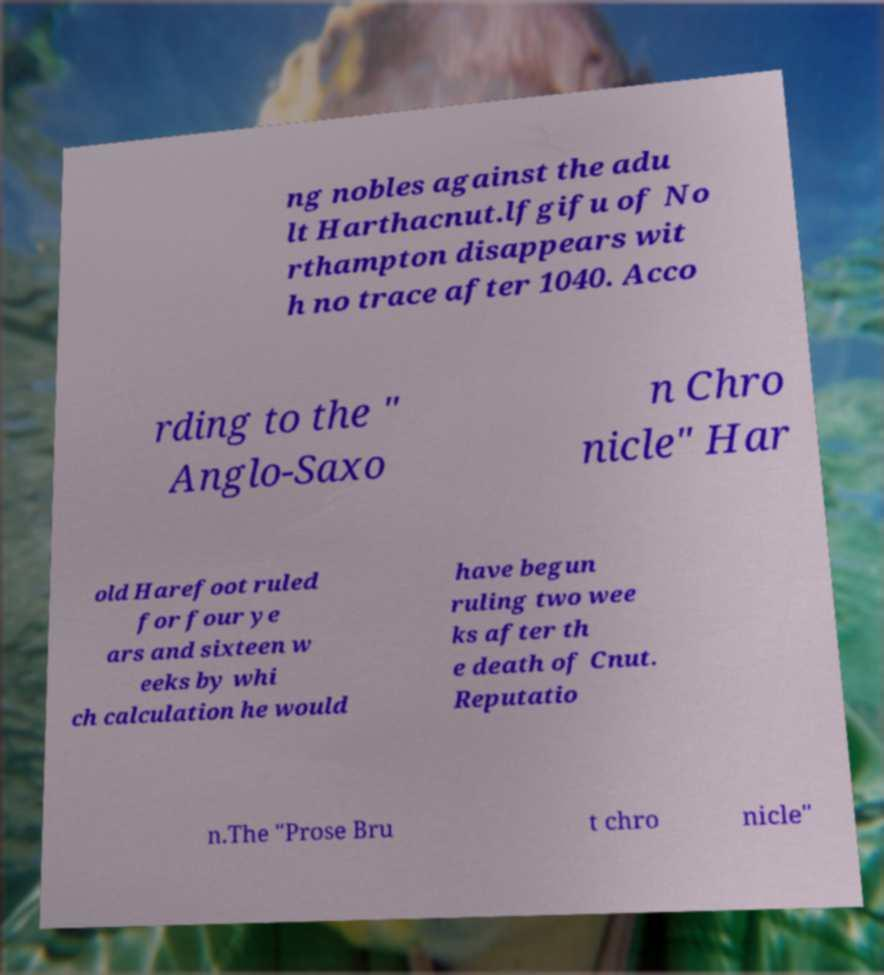Please read and relay the text visible in this image. What does it say? ng nobles against the adu lt Harthacnut.lfgifu of No rthampton disappears wit h no trace after 1040. Acco rding to the " Anglo-Saxo n Chro nicle" Har old Harefoot ruled for four ye ars and sixteen w eeks by whi ch calculation he would have begun ruling two wee ks after th e death of Cnut. Reputatio n.The "Prose Bru t chro nicle" 